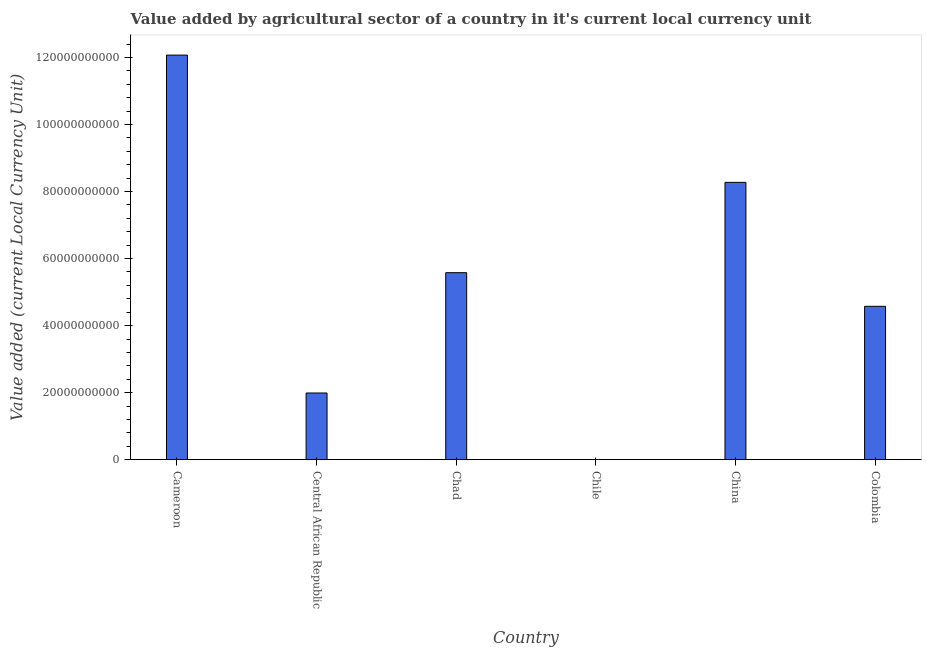What is the title of the graph?
Your answer should be compact. Value added by agricultural sector of a country in it's current local currency unit. What is the label or title of the Y-axis?
Provide a succinct answer. Value added (current Local Currency Unit). What is the value added by agriculture sector in Central African Republic?
Offer a terse response. 1.99e+1. Across all countries, what is the maximum value added by agriculture sector?
Ensure brevity in your answer.  1.21e+11. Across all countries, what is the minimum value added by agriculture sector?
Keep it short and to the point. 1.95e+07. In which country was the value added by agriculture sector maximum?
Your answer should be compact. Cameroon. What is the sum of the value added by agriculture sector?
Your response must be concise. 3.25e+11. What is the difference between the value added by agriculture sector in Chile and Colombia?
Ensure brevity in your answer.  -4.57e+1. What is the average value added by agriculture sector per country?
Offer a terse response. 5.42e+1. What is the median value added by agriculture sector?
Give a very brief answer. 5.08e+1. In how many countries, is the value added by agriculture sector greater than 4000000000 LCU?
Provide a succinct answer. 5. What is the ratio of the value added by agriculture sector in Cameroon to that in Colombia?
Offer a terse response. 2.64. Is the value added by agriculture sector in Central African Republic less than that in Chad?
Give a very brief answer. Yes. Is the difference between the value added by agriculture sector in Cameroon and China greater than the difference between any two countries?
Offer a terse response. No. What is the difference between the highest and the second highest value added by agriculture sector?
Your response must be concise. 3.80e+1. What is the difference between the highest and the lowest value added by agriculture sector?
Give a very brief answer. 1.21e+11. In how many countries, is the value added by agriculture sector greater than the average value added by agriculture sector taken over all countries?
Your answer should be compact. 3. How many countries are there in the graph?
Offer a terse response. 6. Are the values on the major ticks of Y-axis written in scientific E-notation?
Provide a short and direct response. No. What is the Value added (current Local Currency Unit) of Cameroon?
Your answer should be very brief. 1.21e+11. What is the Value added (current Local Currency Unit) in Central African Republic?
Give a very brief answer. 1.99e+1. What is the Value added (current Local Currency Unit) of Chad?
Your answer should be compact. 5.58e+1. What is the Value added (current Local Currency Unit) of Chile?
Your response must be concise. 1.95e+07. What is the Value added (current Local Currency Unit) of China?
Provide a short and direct response. 8.27e+1. What is the Value added (current Local Currency Unit) of Colombia?
Offer a very short reply. 4.58e+1. What is the difference between the Value added (current Local Currency Unit) in Cameroon and Central African Republic?
Your answer should be very brief. 1.01e+11. What is the difference between the Value added (current Local Currency Unit) in Cameroon and Chad?
Your answer should be very brief. 6.49e+1. What is the difference between the Value added (current Local Currency Unit) in Cameroon and Chile?
Your answer should be very brief. 1.21e+11. What is the difference between the Value added (current Local Currency Unit) in Cameroon and China?
Ensure brevity in your answer.  3.80e+1. What is the difference between the Value added (current Local Currency Unit) in Cameroon and Colombia?
Offer a terse response. 7.49e+1. What is the difference between the Value added (current Local Currency Unit) in Central African Republic and Chad?
Your response must be concise. -3.59e+1. What is the difference between the Value added (current Local Currency Unit) in Central African Republic and Chile?
Provide a short and direct response. 1.99e+1. What is the difference between the Value added (current Local Currency Unit) in Central African Republic and China?
Offer a very short reply. -6.28e+1. What is the difference between the Value added (current Local Currency Unit) in Central African Republic and Colombia?
Provide a succinct answer. -2.59e+1. What is the difference between the Value added (current Local Currency Unit) in Chad and Chile?
Your answer should be very brief. 5.58e+1. What is the difference between the Value added (current Local Currency Unit) in Chad and China?
Your response must be concise. -2.69e+1. What is the difference between the Value added (current Local Currency Unit) in Chad and Colombia?
Give a very brief answer. 1.00e+1. What is the difference between the Value added (current Local Currency Unit) in Chile and China?
Ensure brevity in your answer.  -8.27e+1. What is the difference between the Value added (current Local Currency Unit) in Chile and Colombia?
Offer a very short reply. -4.57e+1. What is the difference between the Value added (current Local Currency Unit) in China and Colombia?
Make the answer very short. 3.70e+1. What is the ratio of the Value added (current Local Currency Unit) in Cameroon to that in Central African Republic?
Make the answer very short. 6.07. What is the ratio of the Value added (current Local Currency Unit) in Cameroon to that in Chad?
Your response must be concise. 2.16. What is the ratio of the Value added (current Local Currency Unit) in Cameroon to that in Chile?
Provide a short and direct response. 6189.74. What is the ratio of the Value added (current Local Currency Unit) in Cameroon to that in China?
Offer a very short reply. 1.46. What is the ratio of the Value added (current Local Currency Unit) in Cameroon to that in Colombia?
Offer a terse response. 2.64. What is the ratio of the Value added (current Local Currency Unit) in Central African Republic to that in Chad?
Offer a very short reply. 0.36. What is the ratio of the Value added (current Local Currency Unit) in Central African Republic to that in Chile?
Ensure brevity in your answer.  1020.51. What is the ratio of the Value added (current Local Currency Unit) in Central African Republic to that in China?
Provide a short and direct response. 0.24. What is the ratio of the Value added (current Local Currency Unit) in Central African Republic to that in Colombia?
Offer a very short reply. 0.43. What is the ratio of the Value added (current Local Currency Unit) in Chad to that in Chile?
Make the answer very short. 2861.17. What is the ratio of the Value added (current Local Currency Unit) in Chad to that in China?
Offer a terse response. 0.67. What is the ratio of the Value added (current Local Currency Unit) in Chad to that in Colombia?
Your answer should be very brief. 1.22. What is the ratio of the Value added (current Local Currency Unit) in Chile to that in Colombia?
Provide a succinct answer. 0. What is the ratio of the Value added (current Local Currency Unit) in China to that in Colombia?
Give a very brief answer. 1.81. 